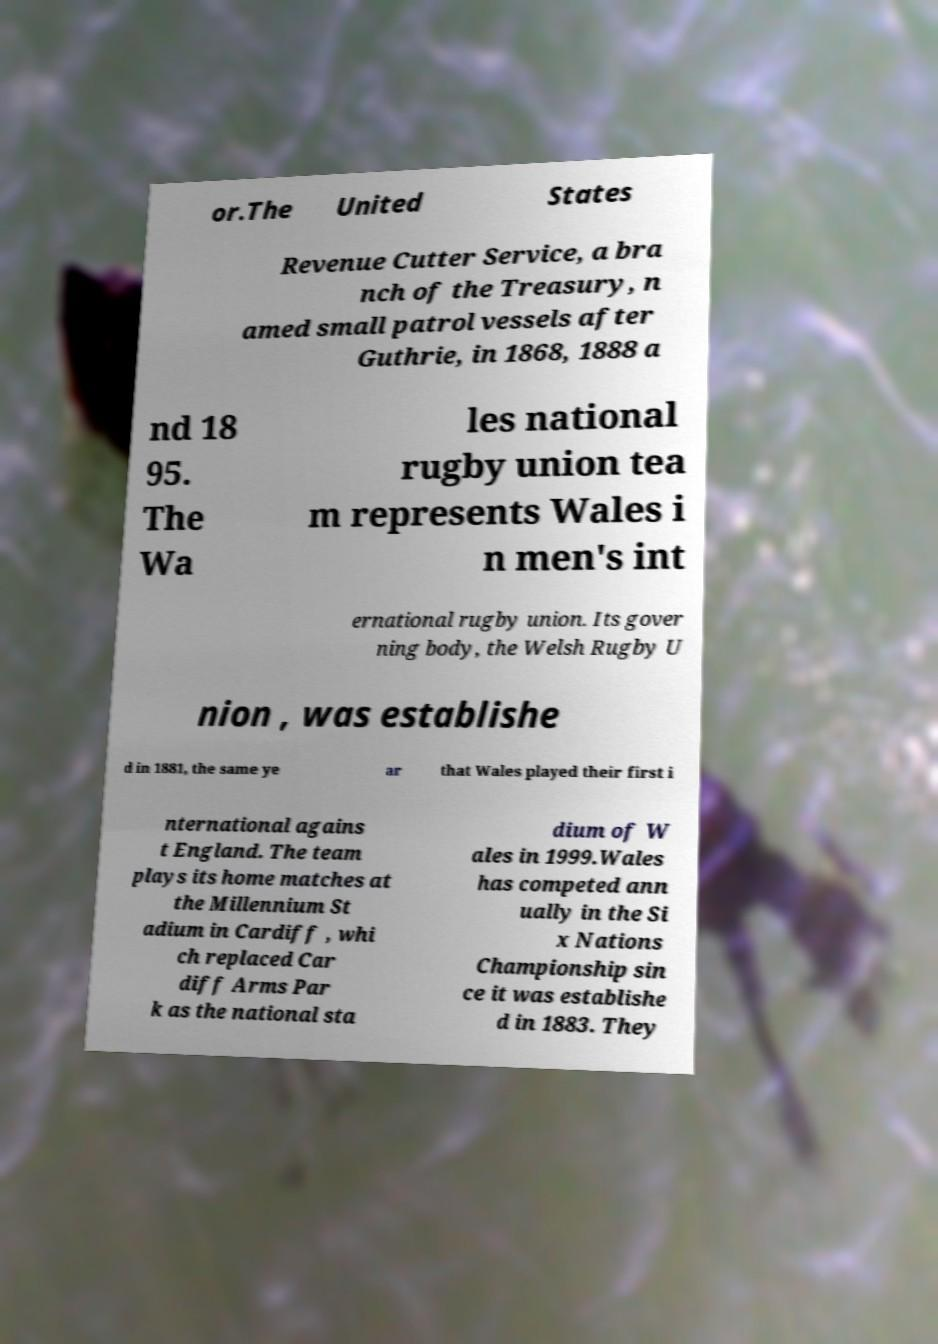There's text embedded in this image that I need extracted. Can you transcribe it verbatim? or.The United States Revenue Cutter Service, a bra nch of the Treasury, n amed small patrol vessels after Guthrie, in 1868, 1888 a nd 18 95. The Wa les national rugby union tea m represents Wales i n men's int ernational rugby union. Its gover ning body, the Welsh Rugby U nion , was establishe d in 1881, the same ye ar that Wales played their first i nternational agains t England. The team plays its home matches at the Millennium St adium in Cardiff , whi ch replaced Car diff Arms Par k as the national sta dium of W ales in 1999.Wales has competed ann ually in the Si x Nations Championship sin ce it was establishe d in 1883. They 